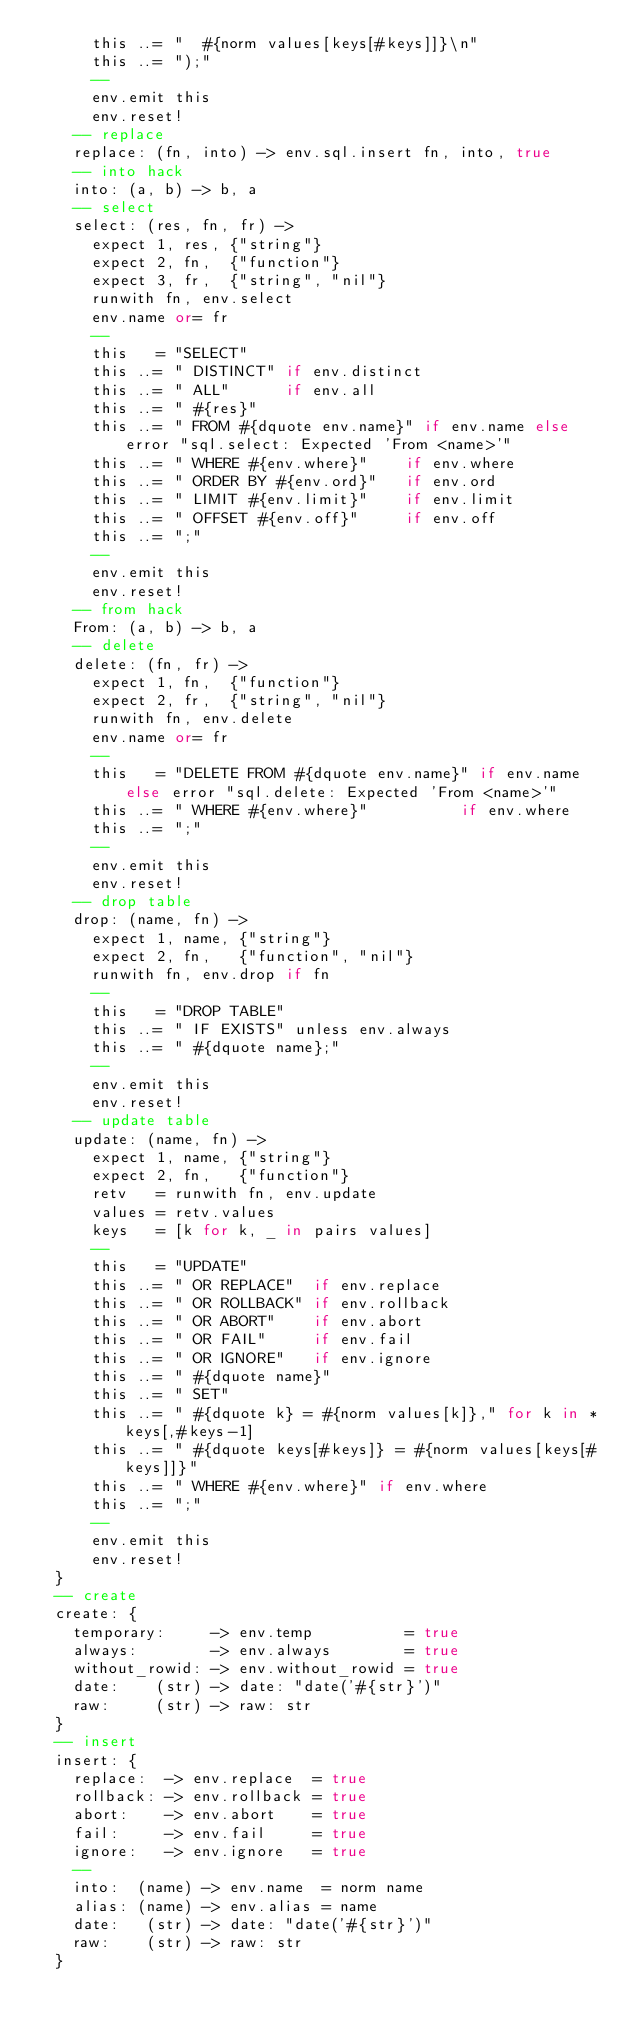<code> <loc_0><loc_0><loc_500><loc_500><_MoonScript_>      this ..= "  #{norm values[keys[#keys]]}\n"
      this ..= ");"
      --
      env.emit this
      env.reset!
    -- replace
    replace: (fn, into) -> env.sql.insert fn, into, true
    -- into hack
    into: (a, b) -> b, a
    -- select
    select: (res, fn, fr) ->
      expect 1, res, {"string"}
      expect 2, fn,  {"function"}
      expect 3, fr,  {"string", "nil"}
      runwith fn, env.select
      env.name or= fr
      --
      this   = "SELECT"
      this ..= " DISTINCT" if env.distinct
      this ..= " ALL"      if env.all
      this ..= " #{res}"
      this ..= " FROM #{dquote env.name}" if env.name else error "sql.select: Expected 'From <name>'"
      this ..= " WHERE #{env.where}"    if env.where
      this ..= " ORDER BY #{env.ord}"   if env.ord
      this ..= " LIMIT #{env.limit}"    if env.limit
      this ..= " OFFSET #{env.off}"     if env.off
      this ..= ";"
      --
      env.emit this
      env.reset!
    -- from hack
    From: (a, b) -> b, a
    -- delete
    delete: (fn, fr) ->
      expect 1, fn,  {"function"}
      expect 2, fr,  {"string", "nil"}
      runwith fn, env.delete
      env.name or= fr
      --
      this   = "DELETE FROM #{dquote env.name}" if env.name else error "sql.delete: Expected 'From <name>'"
      this ..= " WHERE #{env.where}"          if env.where
      this ..= ";"
      --
      env.emit this
      env.reset!
    -- drop table
    drop: (name, fn) ->
      expect 1, name, {"string"}
      expect 2, fn,   {"function", "nil"}
      runwith fn, env.drop if fn
      --
      this   = "DROP TABLE"
      this ..= " IF EXISTS" unless env.always
      this ..= " #{dquote name};"
      --
      env.emit this
      env.reset!
    -- update table
    update: (name, fn) ->
      expect 1, name, {"string"}
      expect 2, fn,   {"function"}
      retv   = runwith fn, env.update
      values = retv.values
      keys   = [k for k, _ in pairs values]
      --
      this   = "UPDATE"
      this ..= " OR REPLACE"  if env.replace
      this ..= " OR ROLLBACK" if env.rollback
      this ..= " OR ABORT"    if env.abort
      this ..= " OR FAIL"     if env.fail
      this ..= " OR IGNORE"   if env.ignore
      this ..= " #{dquote name}"
      this ..= " SET"
      this ..= " #{dquote k} = #{norm values[k]}," for k in *keys[,#keys-1]
      this ..= " #{dquote keys[#keys]} = #{norm values[keys[#keys]]}"
      this ..= " WHERE #{env.where}" if env.where
      this ..= ";"
      --
      env.emit this
      env.reset!
  }
  -- create
  create: {
    temporary:     -> env.temp          = true
    always:        -> env.always        = true
    without_rowid: -> env.without_rowid = true
    date:    (str) -> date: "date('#{str}')"
    raw:     (str) -> raw: str
  }
  -- insert
  insert: {
    replace:  -> env.replace  = true
    rollback: -> env.rollback = true
    abort:    -> env.abort    = true
    fail:     -> env.fail     = true
    ignore:   -> env.ignore   = true
    --
    into:  (name) -> env.name  = norm name
    alias: (name) -> env.alias = name
    date:   (str) -> date: "date('#{str}')"
    raw:    (str) -> raw: str
  }</code> 